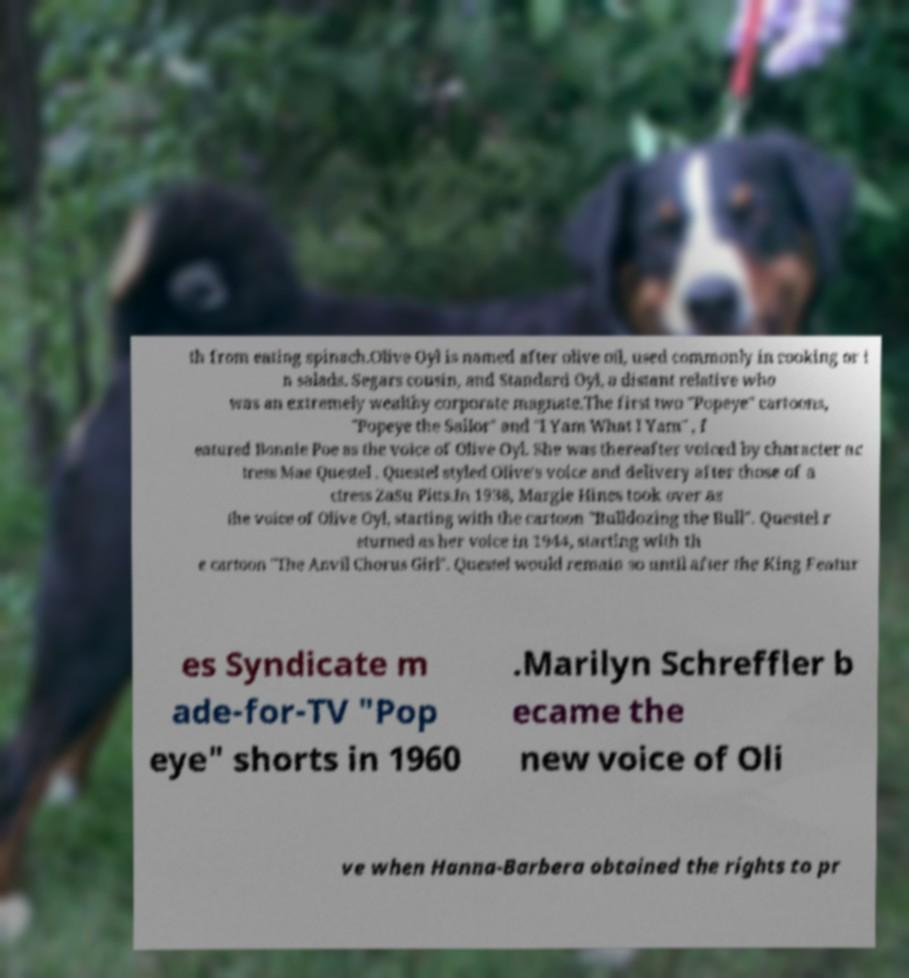Could you assist in decoding the text presented in this image and type it out clearly? th from eating spinach.Olive Oyl is named after olive oil, used commonly in cooking or i n salads. Segars cousin, and Standard Oyl, a distant relative who was an extremely wealthy corporate magnate.The first two "Popeye" cartoons, "Popeye the Sailor" and "I Yam What I Yam" , f eatured Bonnie Poe as the voice of Olive Oyl. She was thereafter voiced by character ac tress Mae Questel . Questel styled Olive's voice and delivery after those of a ctress ZaSu Pitts.In 1938, Margie Hines took over as the voice of Olive Oyl, starting with the cartoon "Bulldozing the Bull". Questel r eturned as her voice in 1944, starting with th e cartoon "The Anvil Chorus Girl". Questel would remain so until after the King Featur es Syndicate m ade-for-TV "Pop eye" shorts in 1960 .Marilyn Schreffler b ecame the new voice of Oli ve when Hanna-Barbera obtained the rights to pr 